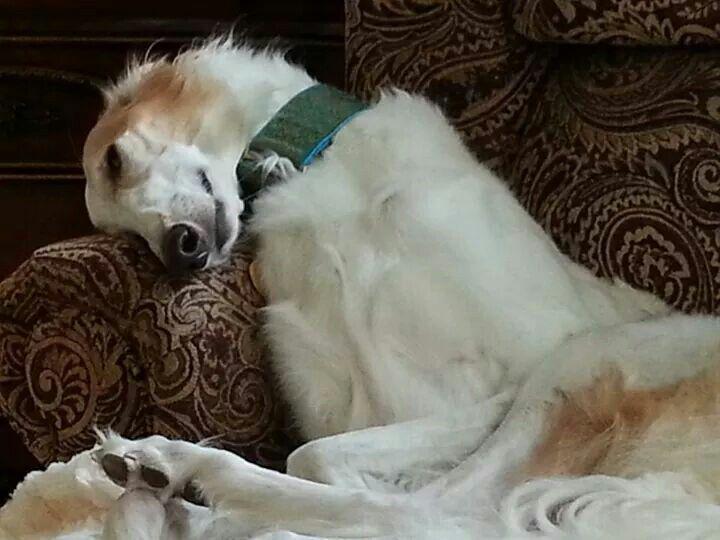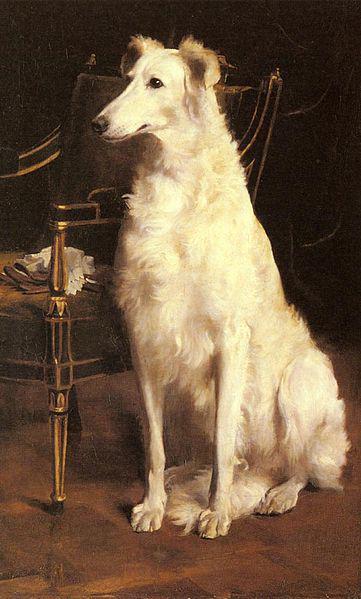The first image is the image on the left, the second image is the image on the right. Considering the images on both sides, is "There is exactly one sleeping dog wearing a collar." valid? Answer yes or no. Yes. 